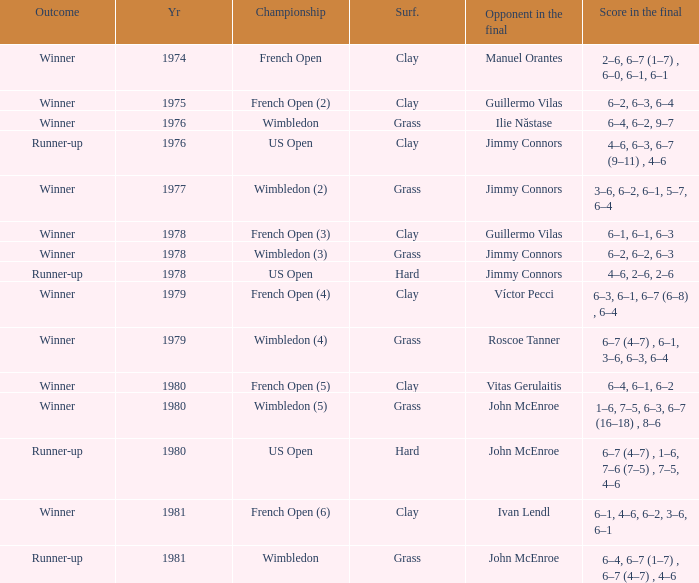What is every year where opponent in the final is John Mcenroe at Wimbledon? 1981.0. 